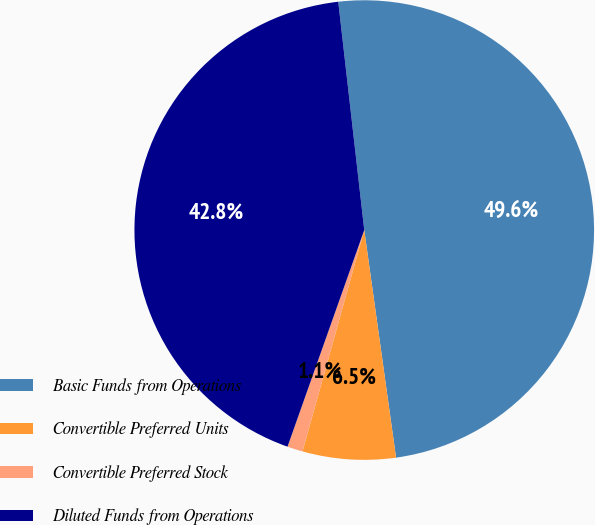<chart> <loc_0><loc_0><loc_500><loc_500><pie_chart><fcel>Basic Funds from Operations<fcel>Convertible Preferred Units<fcel>Convertible Preferred Stock<fcel>Diluted Funds from Operations<nl><fcel>49.6%<fcel>6.54%<fcel>1.09%<fcel>42.78%<nl></chart> 